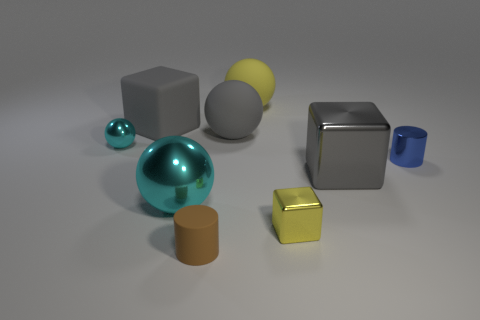There is a metallic thing that is both on the left side of the yellow metallic thing and behind the large shiny sphere; how big is it?
Offer a very short reply. Small. How many other things are there of the same shape as the blue thing?
Your answer should be compact. 1. How many spheres are either yellow rubber things or large cyan metallic things?
Provide a short and direct response. 2. Are there any large gray balls on the left side of the big shiny object right of the small brown rubber thing in front of the gray sphere?
Offer a terse response. Yes. What color is the small shiny thing that is the same shape as the big cyan shiny thing?
Your answer should be compact. Cyan. How many yellow things are either tiny shiny blocks or metal things?
Your response must be concise. 1. What material is the cyan ball right of the big gray cube on the left side of the large yellow sphere?
Offer a very short reply. Metal. Is the small yellow metallic object the same shape as the gray metal thing?
Your response must be concise. Yes. The metallic cube that is the same size as the yellow matte thing is what color?
Your answer should be compact. Gray. Are there any large rubber things of the same color as the small cube?
Your answer should be very brief. Yes. 